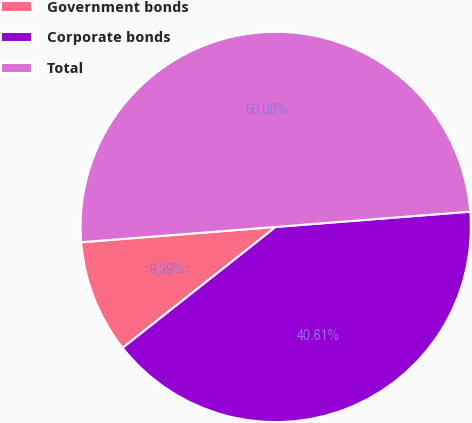Convert chart to OTSL. <chart><loc_0><loc_0><loc_500><loc_500><pie_chart><fcel>Government bonds<fcel>Corporate bonds<fcel>Total<nl><fcel>9.39%<fcel>40.61%<fcel>50.0%<nl></chart> 